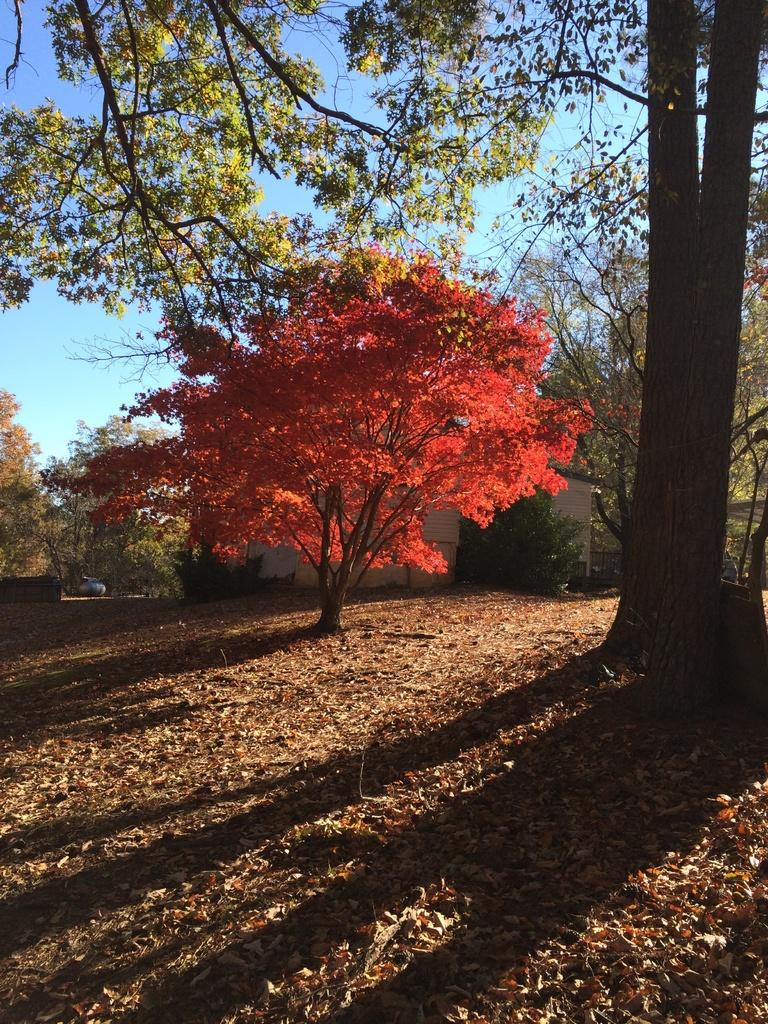What type of vegetation can be seen in the image? There are many trees and plants in the image. What type of structure is visible in the image? There is a house in the image. What is visible in the background of the image? The sky is visible in the background of the image. What can be found on the ground at the bottom of the image? Dry leaves are present on the ground at the bottom of the image. What type of cord is used to hold up the chin of the tree in the image? There is no tree with a chin present in the image, and therefore no cord is needed. 